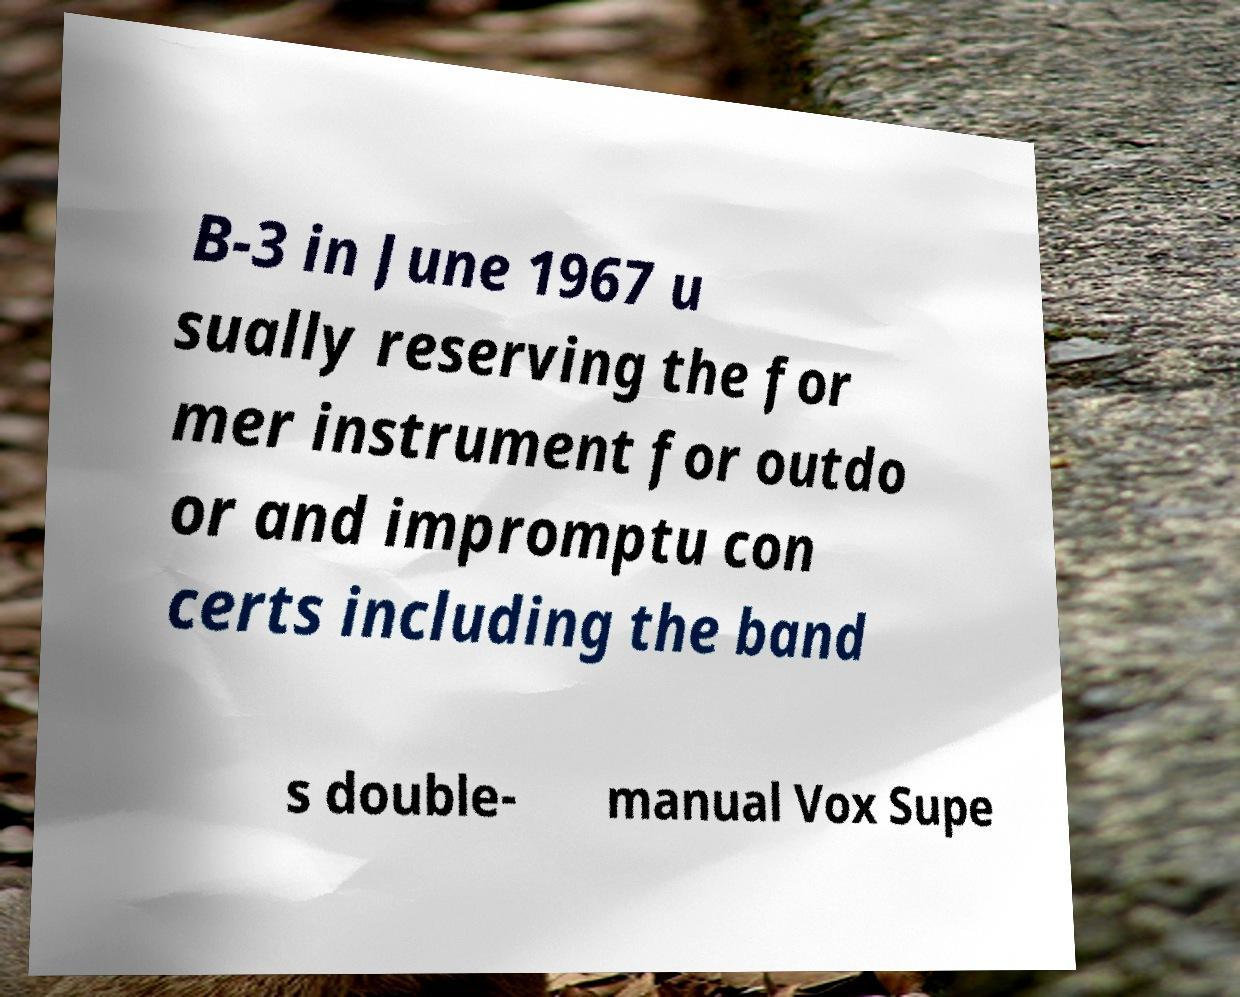Could you assist in decoding the text presented in this image and type it out clearly? B-3 in June 1967 u sually reserving the for mer instrument for outdo or and impromptu con certs including the band s double- manual Vox Supe 